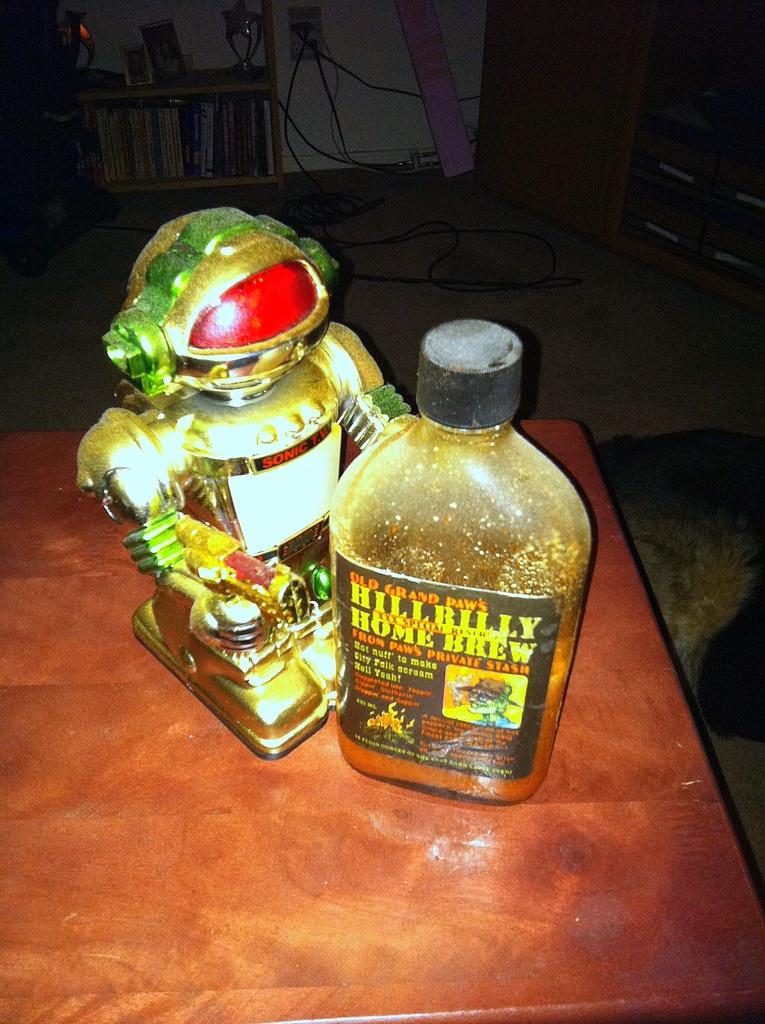Who made this drink?
Offer a terse response. Hillbilly home brew. 